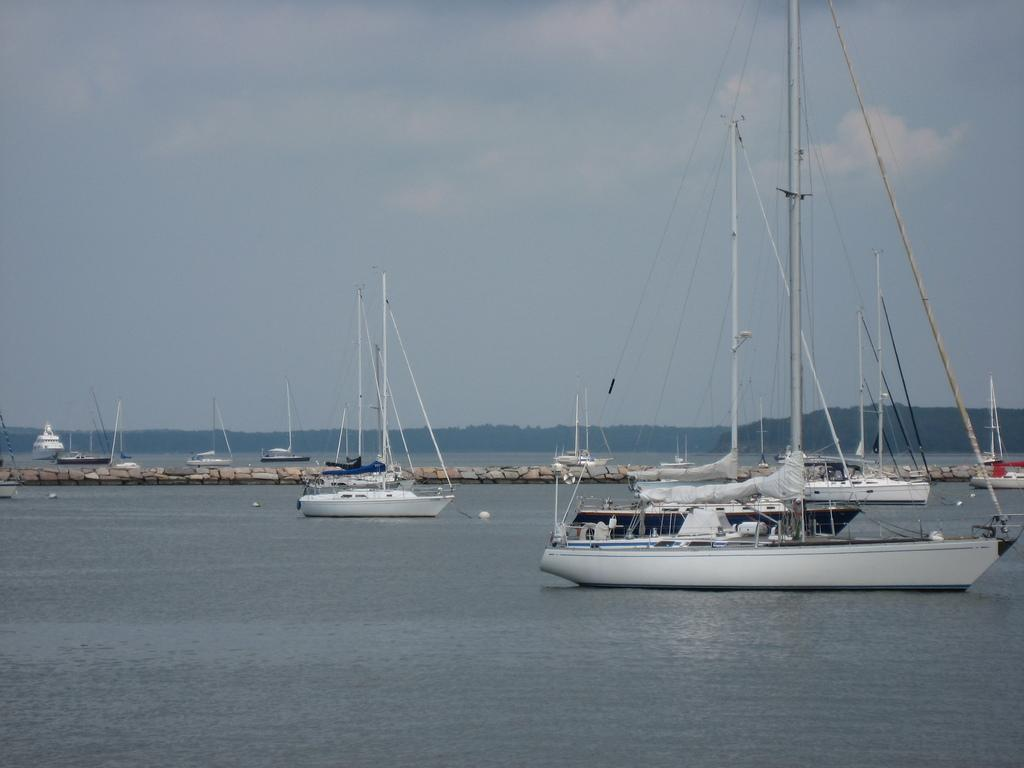What type of vehicles are in the image? There are boats in the image. What color are the boats? The boats are white in color. Where are the boats located? The boats are in the water. What is visible at the top of the image? The sky is visible at the top of the image. What type of committee can be seen organizing the boats in the image? There is no committee present in the image, and the boats are not being organized. What type of rake is being used to clean the boats in the image? There is no rake present in the image, and the boats are not being cleaned. 